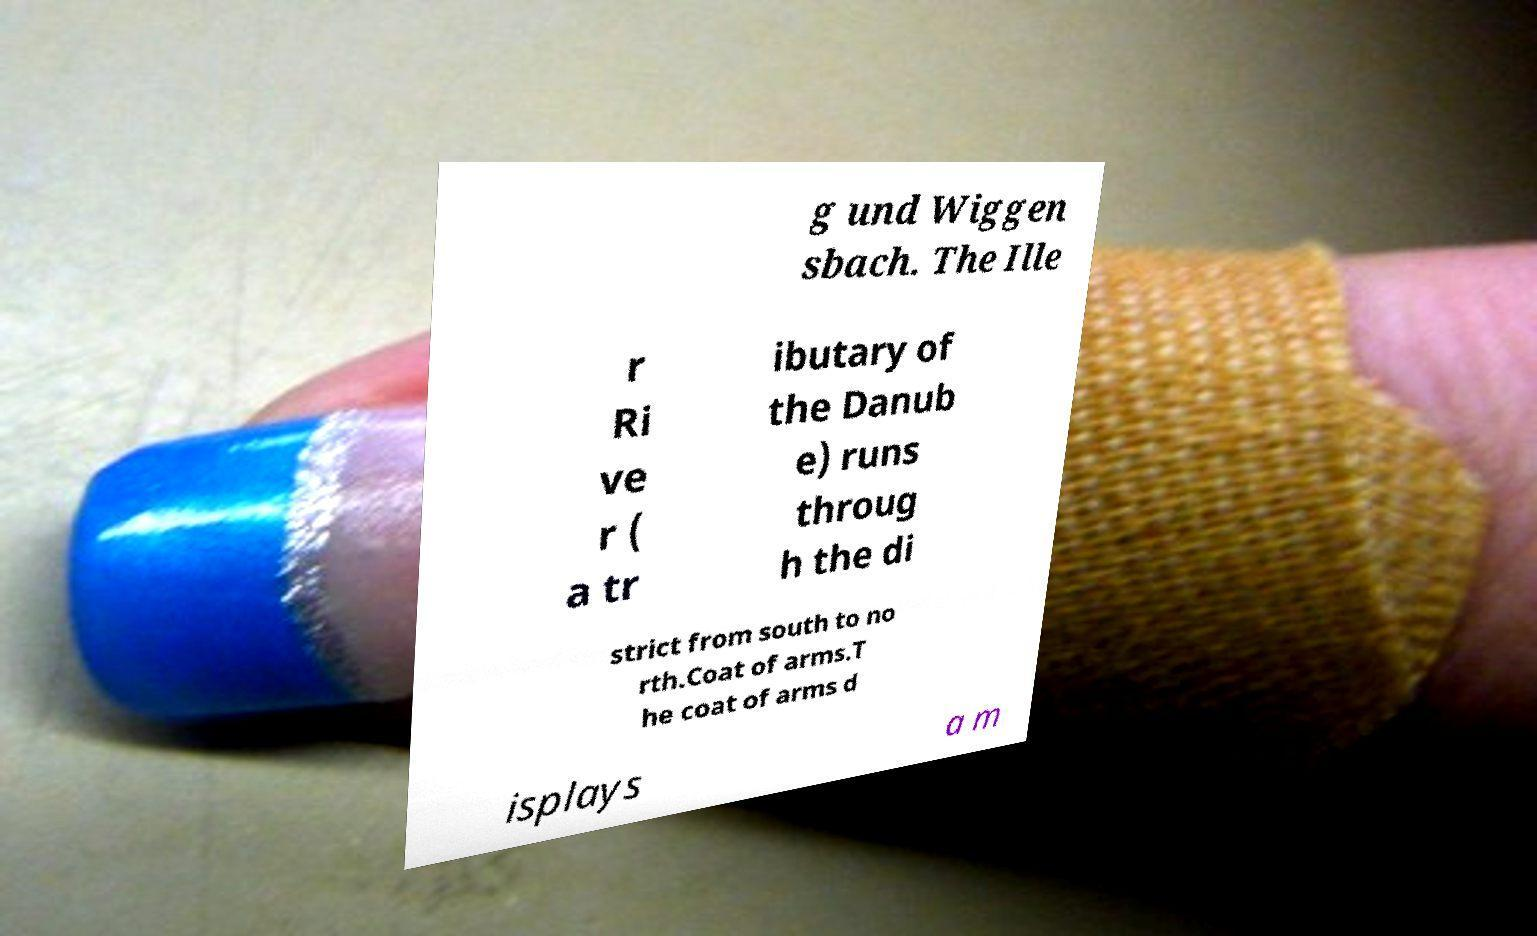What messages or text are displayed in this image? I need them in a readable, typed format. g und Wiggen sbach. The Ille r Ri ve r ( a tr ibutary of the Danub e) runs throug h the di strict from south to no rth.Coat of arms.T he coat of arms d isplays a m 